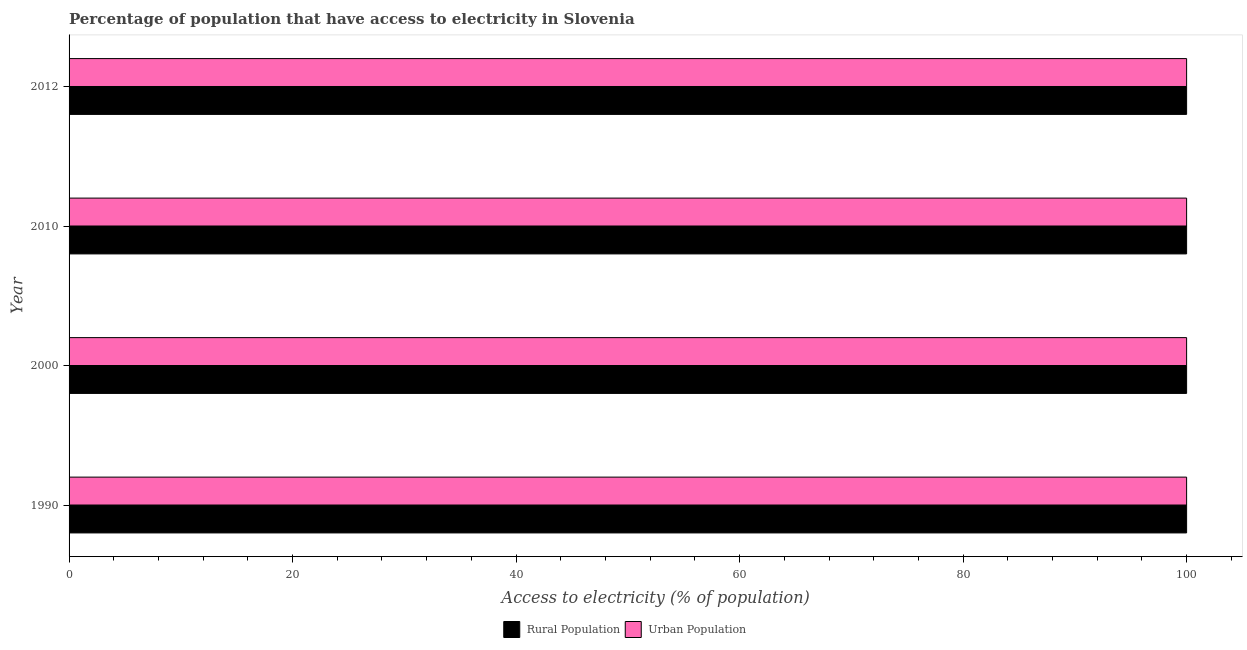How many groups of bars are there?
Your response must be concise. 4. Are the number of bars per tick equal to the number of legend labels?
Your answer should be very brief. Yes. Are the number of bars on each tick of the Y-axis equal?
Your response must be concise. Yes. How many bars are there on the 4th tick from the top?
Your answer should be compact. 2. What is the label of the 3rd group of bars from the top?
Ensure brevity in your answer.  2000. In how many cases, is the number of bars for a given year not equal to the number of legend labels?
Ensure brevity in your answer.  0. What is the percentage of rural population having access to electricity in 1990?
Your answer should be very brief. 100. Across all years, what is the maximum percentage of rural population having access to electricity?
Provide a short and direct response. 100. Across all years, what is the minimum percentage of urban population having access to electricity?
Make the answer very short. 100. In which year was the percentage of urban population having access to electricity minimum?
Provide a short and direct response. 1990. What is the total percentage of rural population having access to electricity in the graph?
Provide a succinct answer. 400. What is the difference between the percentage of rural population having access to electricity in 2010 and that in 2012?
Provide a succinct answer. 0. What is the average percentage of rural population having access to electricity per year?
Make the answer very short. 100. In the year 2010, what is the difference between the percentage of rural population having access to electricity and percentage of urban population having access to electricity?
Make the answer very short. 0. In how many years, is the percentage of rural population having access to electricity greater than 56 %?
Provide a short and direct response. 4. What is the difference between the highest and the second highest percentage of rural population having access to electricity?
Offer a very short reply. 0. Is the sum of the percentage of urban population having access to electricity in 1990 and 2010 greater than the maximum percentage of rural population having access to electricity across all years?
Your answer should be very brief. Yes. What does the 1st bar from the top in 2010 represents?
Provide a short and direct response. Urban Population. What does the 2nd bar from the bottom in 2000 represents?
Give a very brief answer. Urban Population. Are all the bars in the graph horizontal?
Your response must be concise. Yes. How many years are there in the graph?
Your answer should be very brief. 4. What is the difference between two consecutive major ticks on the X-axis?
Keep it short and to the point. 20. Are the values on the major ticks of X-axis written in scientific E-notation?
Provide a short and direct response. No. Does the graph contain any zero values?
Give a very brief answer. No. Where does the legend appear in the graph?
Keep it short and to the point. Bottom center. How are the legend labels stacked?
Ensure brevity in your answer.  Horizontal. What is the title of the graph?
Give a very brief answer. Percentage of population that have access to electricity in Slovenia. Does "Mobile cellular" appear as one of the legend labels in the graph?
Provide a short and direct response. No. What is the label or title of the X-axis?
Your answer should be very brief. Access to electricity (% of population). What is the label or title of the Y-axis?
Offer a very short reply. Year. What is the Access to electricity (% of population) of Rural Population in 1990?
Provide a short and direct response. 100. What is the Access to electricity (% of population) of Rural Population in 2000?
Make the answer very short. 100. What is the Access to electricity (% of population) of Urban Population in 2000?
Provide a succinct answer. 100. What is the Access to electricity (% of population) of Urban Population in 2010?
Provide a succinct answer. 100. What is the Access to electricity (% of population) of Rural Population in 2012?
Your answer should be compact. 100. Across all years, what is the minimum Access to electricity (% of population) in Rural Population?
Keep it short and to the point. 100. Across all years, what is the minimum Access to electricity (% of population) in Urban Population?
Provide a short and direct response. 100. What is the total Access to electricity (% of population) of Rural Population in the graph?
Give a very brief answer. 400. What is the difference between the Access to electricity (% of population) in Rural Population in 1990 and that in 2000?
Make the answer very short. 0. What is the difference between the Access to electricity (% of population) in Urban Population in 1990 and that in 2000?
Your answer should be compact. 0. What is the difference between the Access to electricity (% of population) of Rural Population in 1990 and that in 2012?
Your response must be concise. 0. What is the difference between the Access to electricity (% of population) in Urban Population in 1990 and that in 2012?
Offer a very short reply. 0. What is the difference between the Access to electricity (% of population) of Urban Population in 2000 and that in 2010?
Give a very brief answer. 0. What is the difference between the Access to electricity (% of population) of Rural Population in 2000 and that in 2012?
Make the answer very short. 0. What is the difference between the Access to electricity (% of population) in Rural Population in 2000 and the Access to electricity (% of population) in Urban Population in 2010?
Make the answer very short. 0. What is the difference between the Access to electricity (% of population) in Rural Population in 2000 and the Access to electricity (% of population) in Urban Population in 2012?
Give a very brief answer. 0. In the year 2010, what is the difference between the Access to electricity (% of population) of Rural Population and Access to electricity (% of population) of Urban Population?
Your response must be concise. 0. What is the ratio of the Access to electricity (% of population) of Urban Population in 1990 to that in 2000?
Provide a short and direct response. 1. What is the ratio of the Access to electricity (% of population) of Rural Population in 1990 to that in 2010?
Offer a very short reply. 1. What is the ratio of the Access to electricity (% of population) of Rural Population in 2000 to that in 2010?
Offer a very short reply. 1. What is the ratio of the Access to electricity (% of population) in Urban Population in 2000 to that in 2010?
Your answer should be very brief. 1. What is the ratio of the Access to electricity (% of population) in Rural Population in 2010 to that in 2012?
Provide a short and direct response. 1. What is the ratio of the Access to electricity (% of population) in Urban Population in 2010 to that in 2012?
Provide a succinct answer. 1. What is the difference between the highest and the second highest Access to electricity (% of population) of Rural Population?
Give a very brief answer. 0. What is the difference between the highest and the second highest Access to electricity (% of population) of Urban Population?
Ensure brevity in your answer.  0. What is the difference between the highest and the lowest Access to electricity (% of population) of Rural Population?
Provide a succinct answer. 0. What is the difference between the highest and the lowest Access to electricity (% of population) of Urban Population?
Ensure brevity in your answer.  0. 